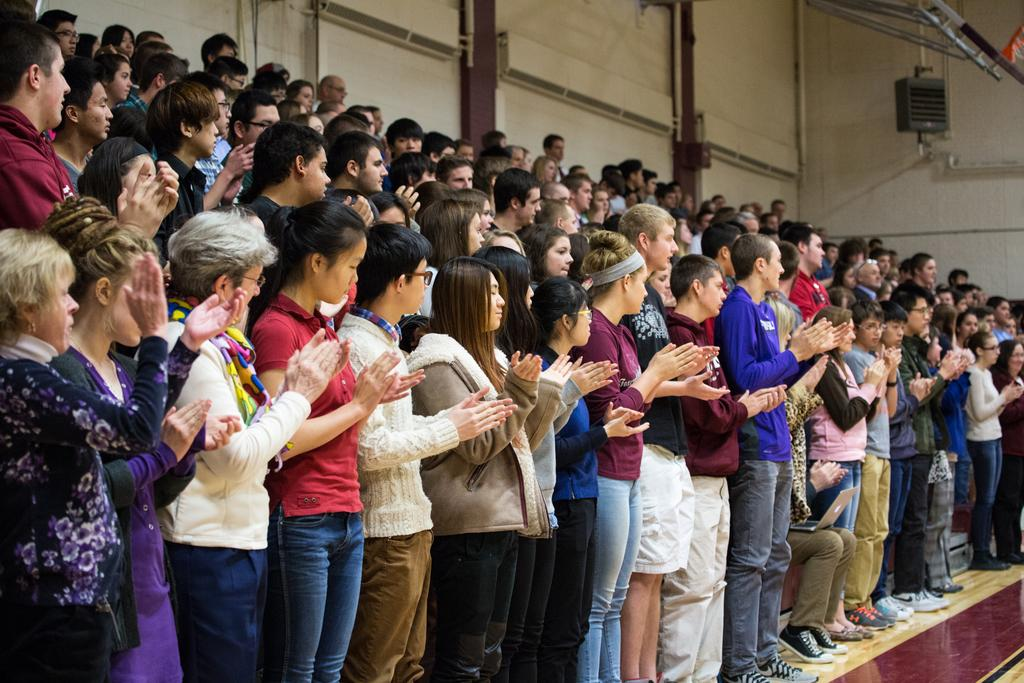How many people are in the image? There is a group of persons in the image. What are the persons in the image doing? The persons are standing and clapping their hands. Can you describe any additional objects in the image? There are some other objects in the right top corner of the image. What is the opinion of the friend sitting next to the passenger in the image? There is no friend or passenger present in the image, so it is not possible to determine their opinions. 